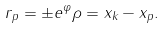Convert formula to latex. <formula><loc_0><loc_0><loc_500><loc_500>r _ { p } = \pm e ^ { \varphi } \rho = x _ { k } - x _ { p } .</formula> 